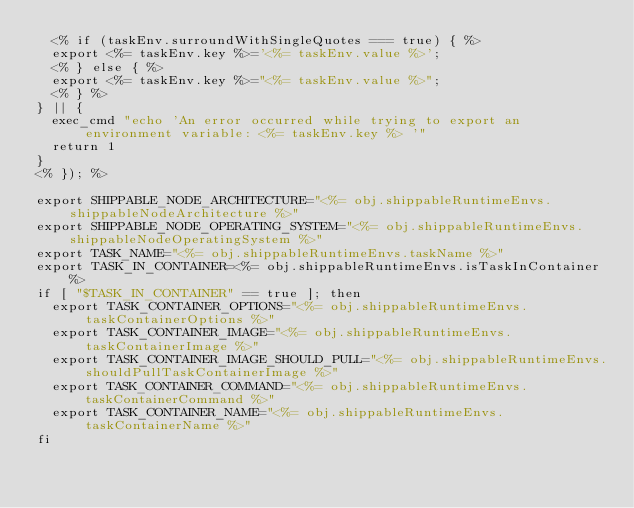Convert code to text. <code><loc_0><loc_0><loc_500><loc_500><_Bash_>  <% if (taskEnv.surroundWithSingleQuotes === true) { %>
  export <%= taskEnv.key %>='<%= taskEnv.value %>';
  <% } else { %>
  export <%= taskEnv.key %>="<%= taskEnv.value %>";
  <% } %>
} || {
  exec_cmd "echo 'An error occurred while trying to export an environment variable: <%= taskEnv.key %> '"
  return 1
}
<% }); %>

export SHIPPABLE_NODE_ARCHITECTURE="<%= obj.shippableRuntimeEnvs.shippableNodeArchitecture %>"
export SHIPPABLE_NODE_OPERATING_SYSTEM="<%= obj.shippableRuntimeEnvs.shippableNodeOperatingSystem %>"
export TASK_NAME="<%= obj.shippableRuntimeEnvs.taskName %>"
export TASK_IN_CONTAINER=<%= obj.shippableRuntimeEnvs.isTaskInContainer %>
if [ "$TASK_IN_CONTAINER" == true ]; then
  export TASK_CONTAINER_OPTIONS="<%= obj.shippableRuntimeEnvs.taskContainerOptions %>"
  export TASK_CONTAINER_IMAGE="<%= obj.shippableRuntimeEnvs.taskContainerImage %>"
  export TASK_CONTAINER_IMAGE_SHOULD_PULL="<%= obj.shippableRuntimeEnvs.shouldPullTaskContainerImage %>"
  export TASK_CONTAINER_COMMAND="<%= obj.shippableRuntimeEnvs.taskContainerCommand %>"
  export TASK_CONTAINER_NAME="<%= obj.shippableRuntimeEnvs.taskContainerName %>"
fi
</code> 